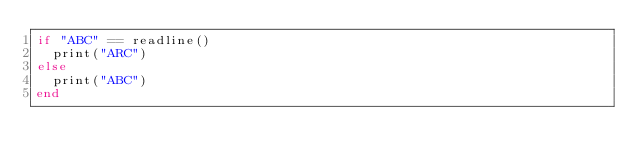<code> <loc_0><loc_0><loc_500><loc_500><_Julia_>if "ABC" == readline()
  print("ARC")
else
  print("ABC")
end</code> 